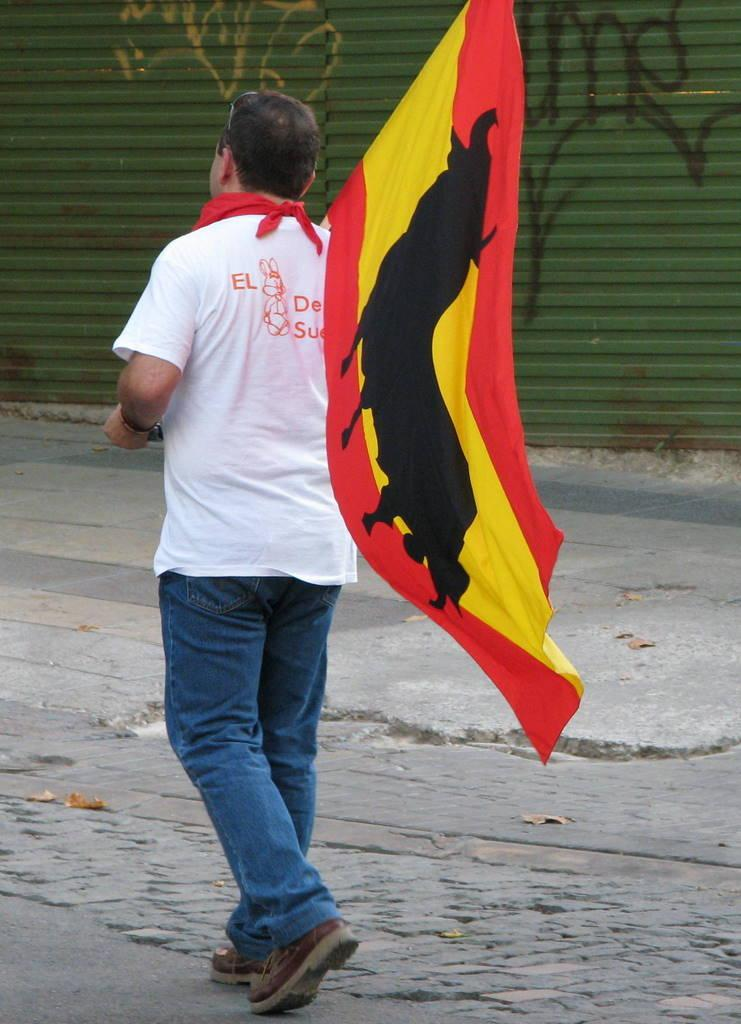What is the person in the image doing? The person in the image is walking. What is the person holding while walking? The person is holding a flag. On what surface is the person walking? The person is walking on a road. What can be seen in the background of the image? There is a shutter in the background of the image. What time of day is it in the image, given the presence of a chin? There is no chin present in the image, and therefore we cannot determine the time of day based on that information. 